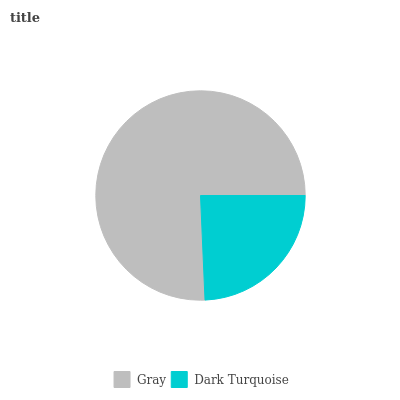Is Dark Turquoise the minimum?
Answer yes or no. Yes. Is Gray the maximum?
Answer yes or no. Yes. Is Dark Turquoise the maximum?
Answer yes or no. No. Is Gray greater than Dark Turquoise?
Answer yes or no. Yes. Is Dark Turquoise less than Gray?
Answer yes or no. Yes. Is Dark Turquoise greater than Gray?
Answer yes or no. No. Is Gray less than Dark Turquoise?
Answer yes or no. No. Is Gray the high median?
Answer yes or no. Yes. Is Dark Turquoise the low median?
Answer yes or no. Yes. Is Dark Turquoise the high median?
Answer yes or no. No. Is Gray the low median?
Answer yes or no. No. 